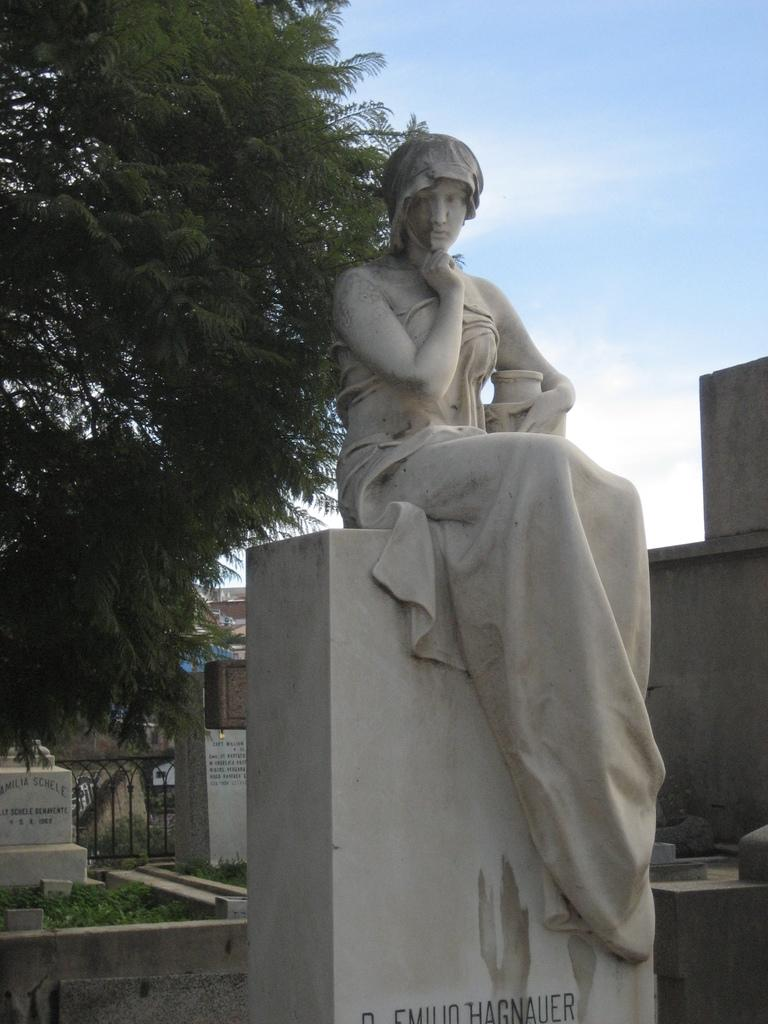What is the main subject in the image? There is a statue in the image. What can be seen in the background of the image? There are buildings in the background of the image. Where is the tree located in the image? The tree is on the left side of the image. What is visible at the top of the image? The sky is visible at the top of the image. What type of coast can be seen in the image? There is no coast visible in the image; it features a statue, buildings, a tree, and the sky. 